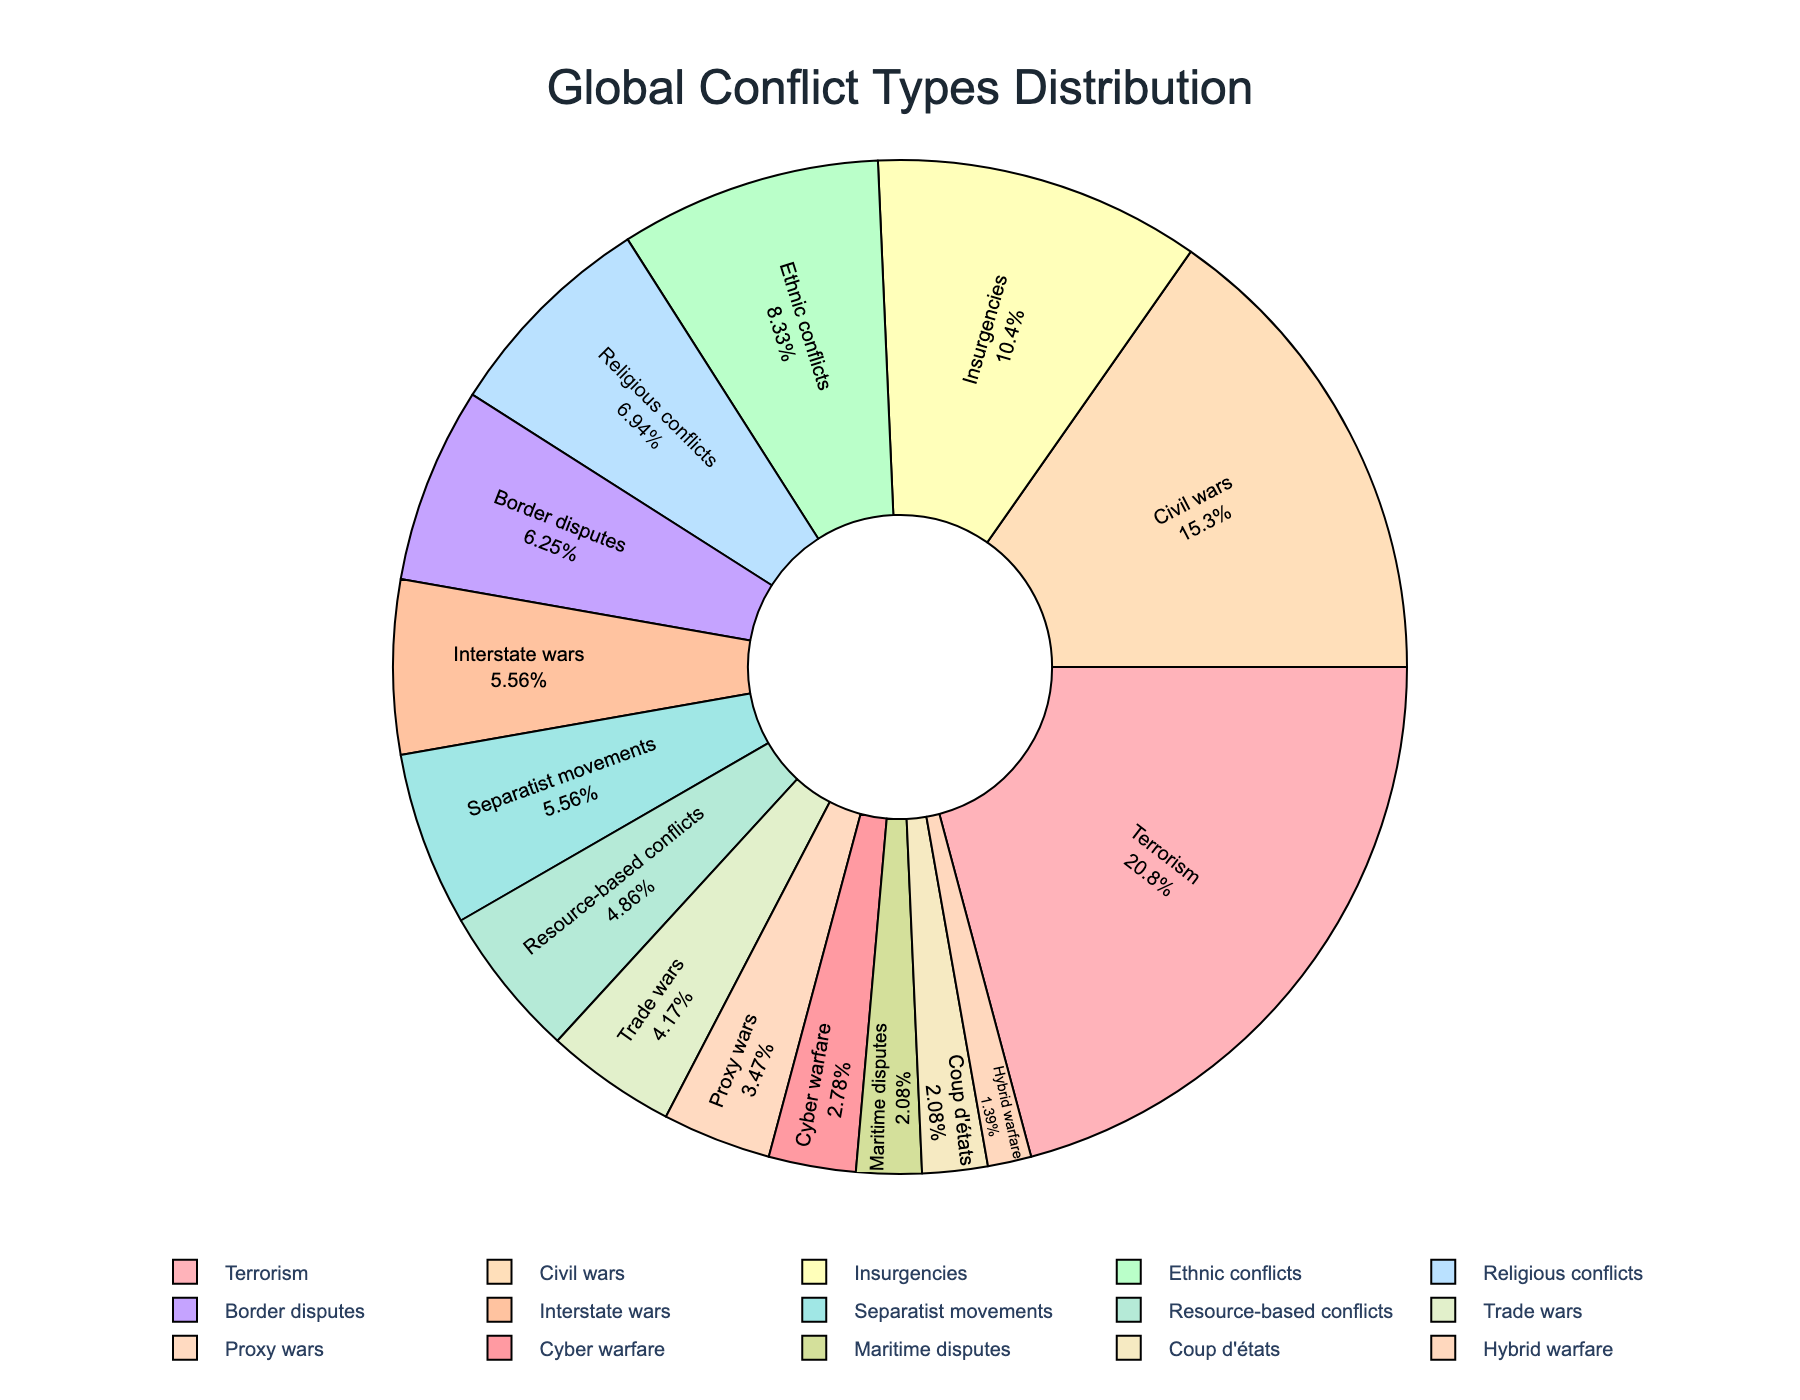What is the most frequent type of conflict? The pie chart shows different types of conflicts and their frequencies. The type with the largest section or highest frequency is the most frequent one.
Answer: Terrorism How many types of conflicts have a frequency higher than 10? To find this, count the sections of the pie chart where the frequency is higher than 10.
Answer: 5 Which conflict type has a frequency closest to Ethnic conflicts? Look at the frequency of Ethnic conflicts on the pie chart (12), then find the closest frequency to this number among the other conflict types.
Answer: Religious conflicts What is the combined frequency of Civil wars, Insurgencies, and Terrorism? Add the frequencies of Civil wars (22), Insurgencies (15), and Terrorism (30). The sum is 22 + 15 + 30.
Answer: 67 Which conflict type is represented by the smallest section of the pie chart? The smallest section corresponds to the type of conflict with the lowest frequency.
Answer: Hybrid warfare How do the frequencies of Religious conflicts and Border disputes compare? Compare the sizes or the numerical values of Religious conflicts (10) and Border disputes (9).
Answer: Religious conflicts are slightly higher What percentage of conflicts are Civil wars? Divide the frequency of Civil wars (22) by the total frequency of all conflicts, then multiply by 100 to get the percentage. (22/144)*100
Answer: 15.3% What is the visual color representation of Interstate wars? Identify the color of the section in the pie chart labeled as Interstate wars.
Answer: (The answer depends on the plot, likely a pastel color from the defined palette) How many conflict types have a frequency lower than 5? Count the sections of the pie chart where the frequency is lower than 5.
Answer: 3 Which conflict types form exactly one-third of the total frequency combined? Calculate the total frequency and find one-third of it, which is 144/3 = 48. Sum the frequencies of conflict types to reach 48 (e.g., Civil wars 22 + Insurgencies 15 + Religious conflicts 10 + Border disputes 9).
Answer: Civil wars, Insurgencies, Religious conflicts 